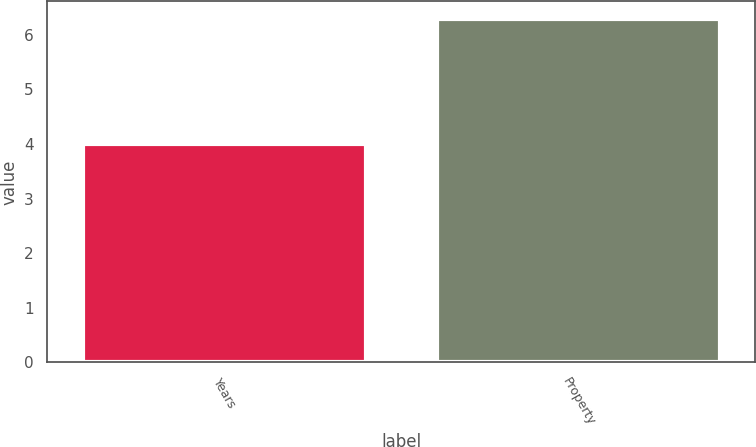<chart> <loc_0><loc_0><loc_500><loc_500><bar_chart><fcel>Years<fcel>Property<nl><fcel>4<fcel>6.3<nl></chart> 